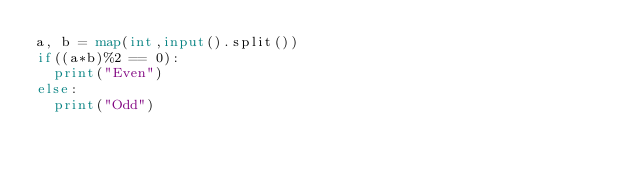Convert code to text. <code><loc_0><loc_0><loc_500><loc_500><_Python_>a, b = map(int,input().split())
if((a*b)%2 == 0):
  print("Even")
else:
  print("Odd")</code> 